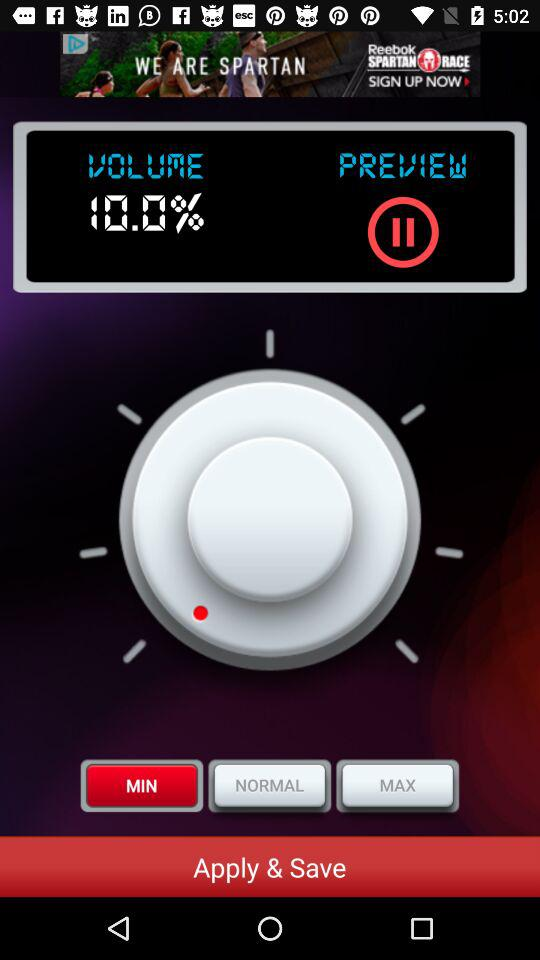What is the set volume? The set volume is 10.0%. 